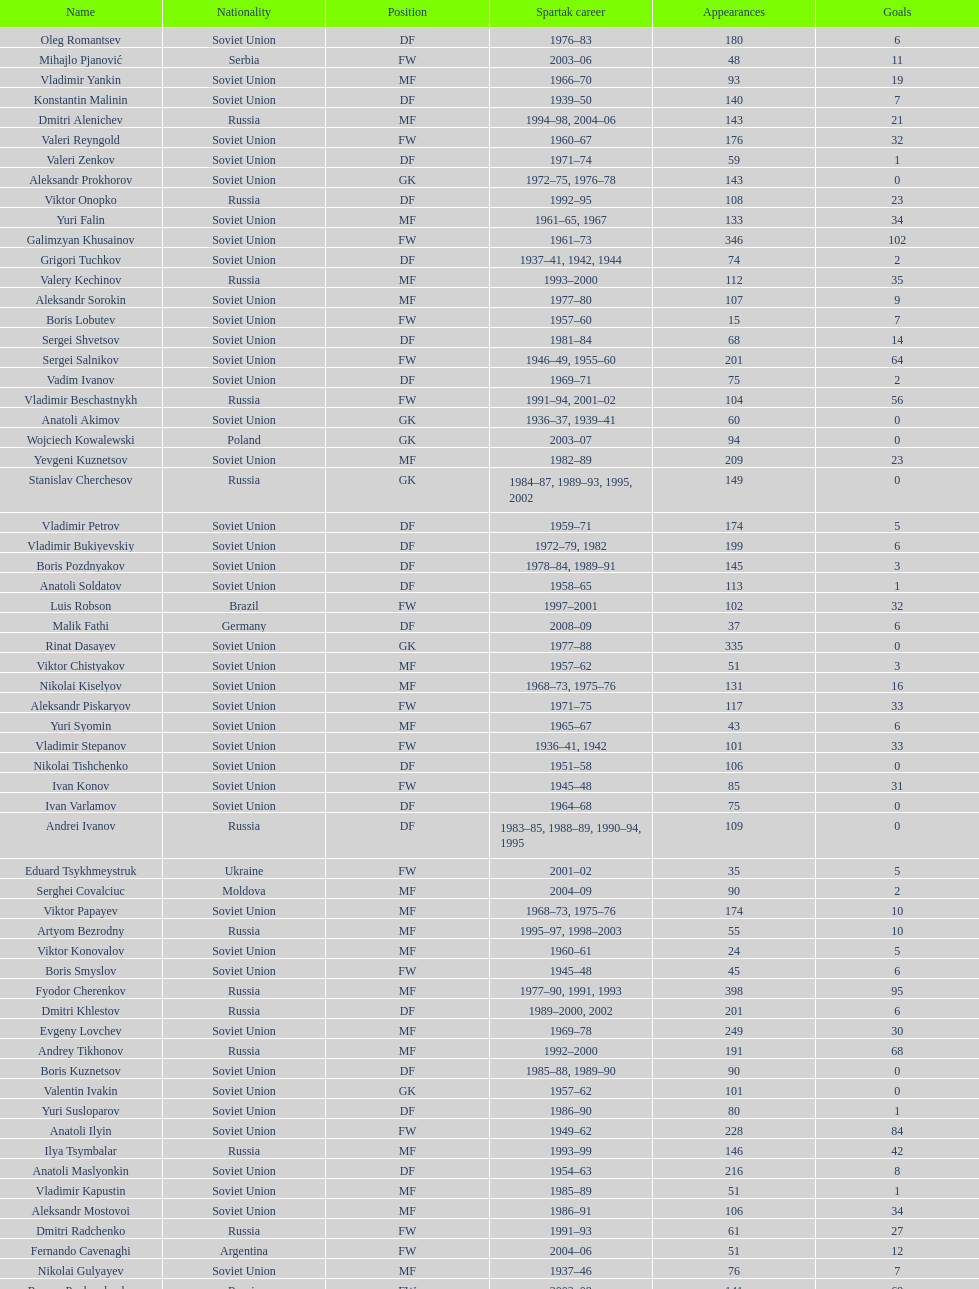Which player has the most appearances with the club? Fyodor Cherenkov. 